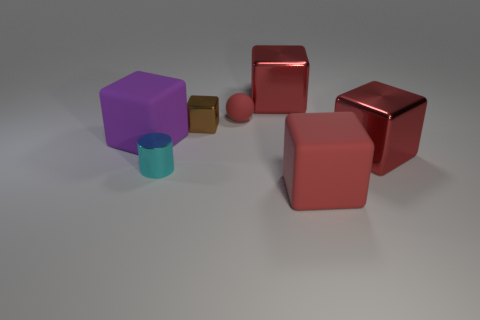There is a red metal cube in front of the big purple block behind the cyan shiny cylinder; what is its size?
Offer a very short reply. Large. There is a block that is in front of the small red ball and behind the purple block; what size is it?
Your answer should be very brief. Small. How many cylinders are the same size as the brown thing?
Your answer should be very brief. 1. What number of metal things are balls or tiny brown objects?
Keep it short and to the point. 1. There is a matte cube that is the same color as the tiny matte ball; what size is it?
Offer a terse response. Large. There is a big cube that is in front of the cyan shiny thing that is right of the big purple rubber thing; what is it made of?
Your answer should be compact. Rubber. How many things are either big red blocks or brown cubes that are on the left side of the small red matte thing?
Keep it short and to the point. 4. The sphere that is made of the same material as the big purple block is what size?
Keep it short and to the point. Small. How many brown things are either shiny cubes or cylinders?
Ensure brevity in your answer.  1. There is another matte thing that is the same color as the small rubber thing; what shape is it?
Offer a very short reply. Cube. 